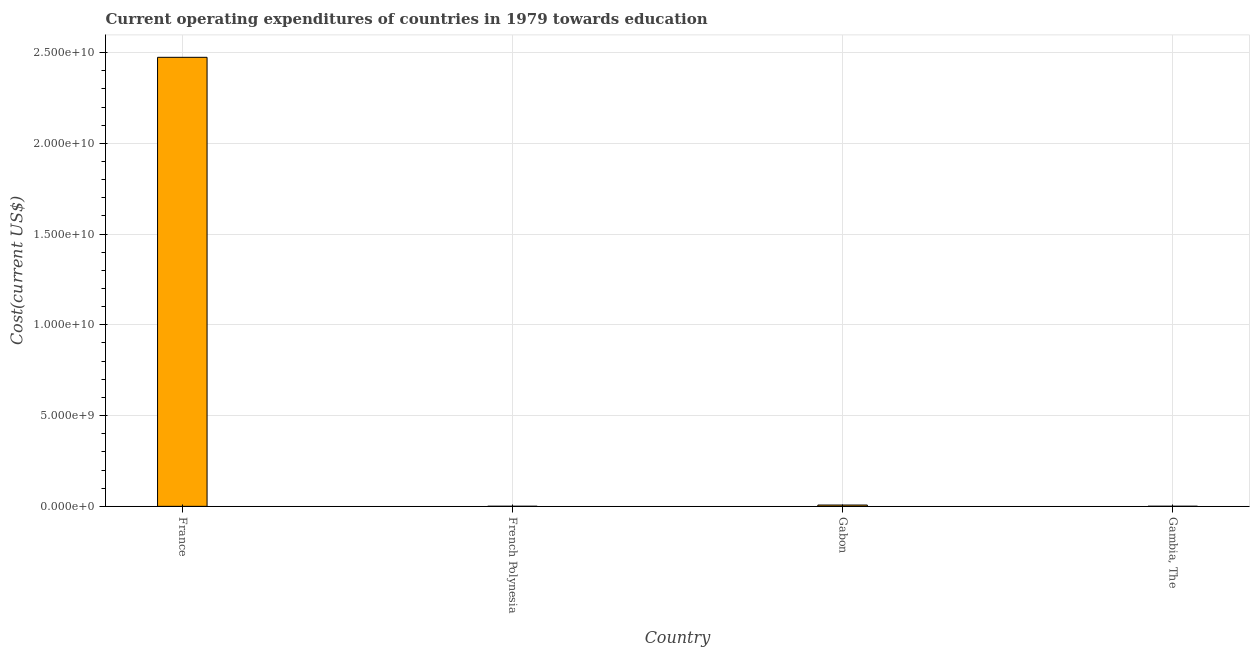Does the graph contain grids?
Provide a short and direct response. Yes. What is the title of the graph?
Provide a short and direct response. Current operating expenditures of countries in 1979 towards education. What is the label or title of the Y-axis?
Make the answer very short. Cost(current US$). What is the education expenditure in Gambia, The?
Ensure brevity in your answer.  5.72e+06. Across all countries, what is the maximum education expenditure?
Your answer should be compact. 2.47e+1. Across all countries, what is the minimum education expenditure?
Provide a succinct answer. 4.56e+06. In which country was the education expenditure minimum?
Your answer should be very brief. French Polynesia. What is the sum of the education expenditure?
Keep it short and to the point. 2.48e+1. What is the difference between the education expenditure in France and Gabon?
Ensure brevity in your answer.  2.47e+1. What is the average education expenditure per country?
Offer a very short reply. 6.21e+09. What is the median education expenditure?
Give a very brief answer. 3.89e+07. In how many countries, is the education expenditure greater than 9000000000 US$?
Your answer should be compact. 1. What is the ratio of the education expenditure in French Polynesia to that in Gambia, The?
Offer a very short reply. 0.8. Is the education expenditure in French Polynesia less than that in Gabon?
Give a very brief answer. Yes. Is the difference between the education expenditure in French Polynesia and Gabon greater than the difference between any two countries?
Make the answer very short. No. What is the difference between the highest and the second highest education expenditure?
Provide a succinct answer. 2.47e+1. What is the difference between the highest and the lowest education expenditure?
Provide a short and direct response. 2.47e+1. How many bars are there?
Keep it short and to the point. 4. Are all the bars in the graph horizontal?
Your answer should be compact. No. How many countries are there in the graph?
Provide a short and direct response. 4. Are the values on the major ticks of Y-axis written in scientific E-notation?
Offer a very short reply. Yes. What is the Cost(current US$) in France?
Offer a very short reply. 2.47e+1. What is the Cost(current US$) in French Polynesia?
Offer a terse response. 4.56e+06. What is the Cost(current US$) in Gabon?
Provide a succinct answer. 7.21e+07. What is the Cost(current US$) in Gambia, The?
Offer a very short reply. 5.72e+06. What is the difference between the Cost(current US$) in France and French Polynesia?
Provide a short and direct response. 2.47e+1. What is the difference between the Cost(current US$) in France and Gabon?
Offer a very short reply. 2.47e+1. What is the difference between the Cost(current US$) in France and Gambia, The?
Keep it short and to the point. 2.47e+1. What is the difference between the Cost(current US$) in French Polynesia and Gabon?
Provide a short and direct response. -6.75e+07. What is the difference between the Cost(current US$) in French Polynesia and Gambia, The?
Offer a very short reply. -1.16e+06. What is the difference between the Cost(current US$) in Gabon and Gambia, The?
Your answer should be very brief. 6.63e+07. What is the ratio of the Cost(current US$) in France to that in French Polynesia?
Offer a very short reply. 5423.42. What is the ratio of the Cost(current US$) in France to that in Gabon?
Ensure brevity in your answer.  343.33. What is the ratio of the Cost(current US$) in France to that in Gambia, The?
Offer a terse response. 4321.69. What is the ratio of the Cost(current US$) in French Polynesia to that in Gabon?
Provide a succinct answer. 0.06. What is the ratio of the Cost(current US$) in French Polynesia to that in Gambia, The?
Give a very brief answer. 0.8. What is the ratio of the Cost(current US$) in Gabon to that in Gambia, The?
Make the answer very short. 12.59. 